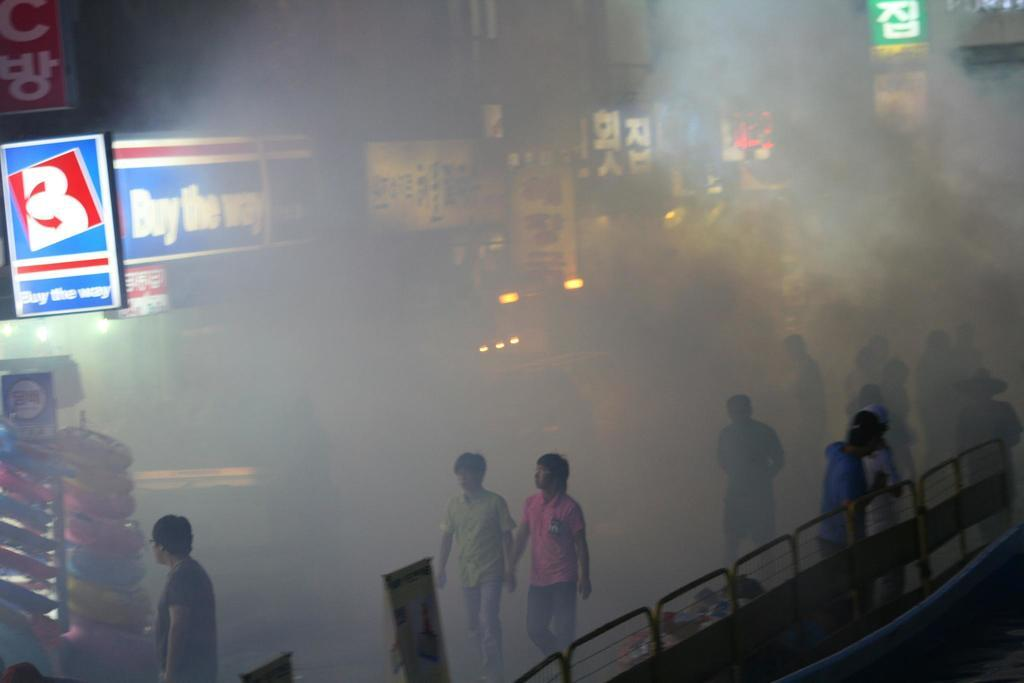Who or what can be seen in the image? There are people in the image. What else is present in the image besides people? There are banners and stores in the image. Can you describe the atmosphere in the image? The area is filled with smoke. What is the manager's behavior like during the week in the image? There is no manager or reference to a specific week in the image, so it's not possible to answer that question. 